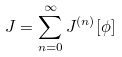<formula> <loc_0><loc_0><loc_500><loc_500>J = \sum _ { n = 0 } ^ { \infty } J ^ { ( n ) } [ \phi ]</formula> 